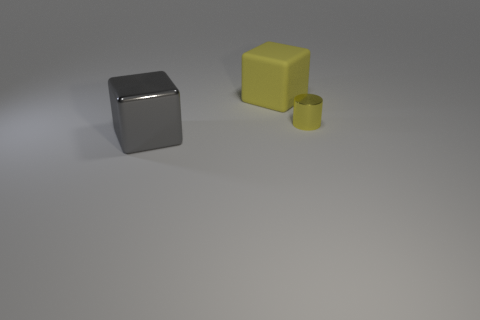Add 2 matte things. How many objects exist? 5 Subtract all blocks. How many objects are left? 1 Subtract all brown blocks. Subtract all rubber blocks. How many objects are left? 2 Add 3 tiny shiny cylinders. How many tiny shiny cylinders are left? 4 Add 3 tiny metallic blocks. How many tiny metallic blocks exist? 3 Subtract 0 red cubes. How many objects are left? 3 